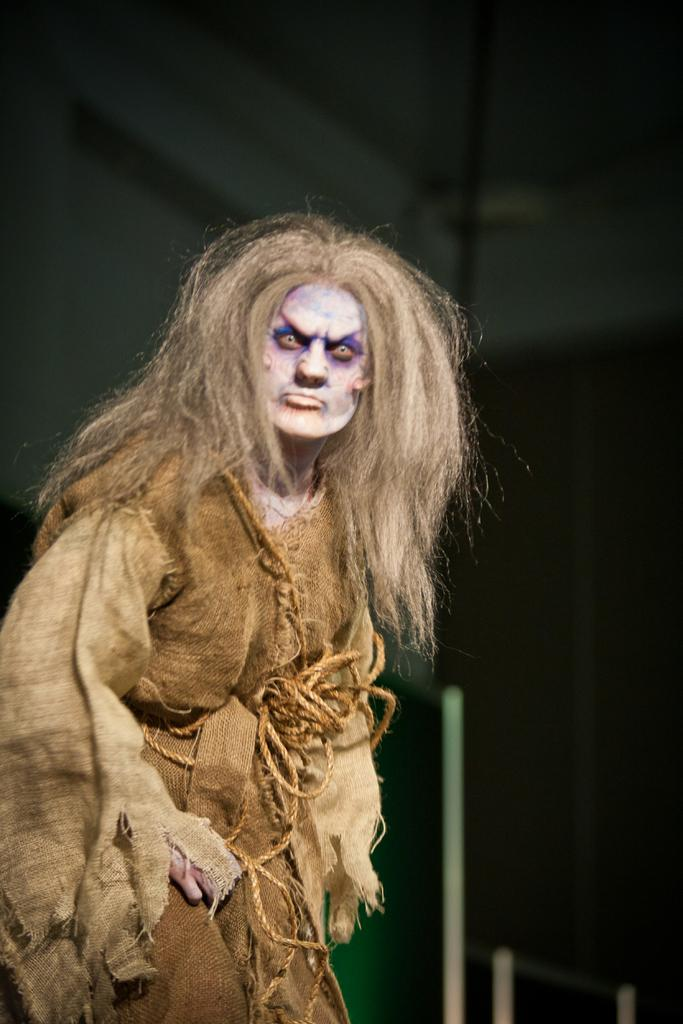What is the person on the left side of the image wearing? There is a person wearing a costume on the left side of the image. What can be seen in the background of the image? There is a wall in the background of the image. What part of a building is visible at the top of the image? The roof is visible at the top of the image. What type of duck is protesting against the use of copper in the image? There is no duck or protest present in the image; it features a person wearing a costume and a wall in the background. 